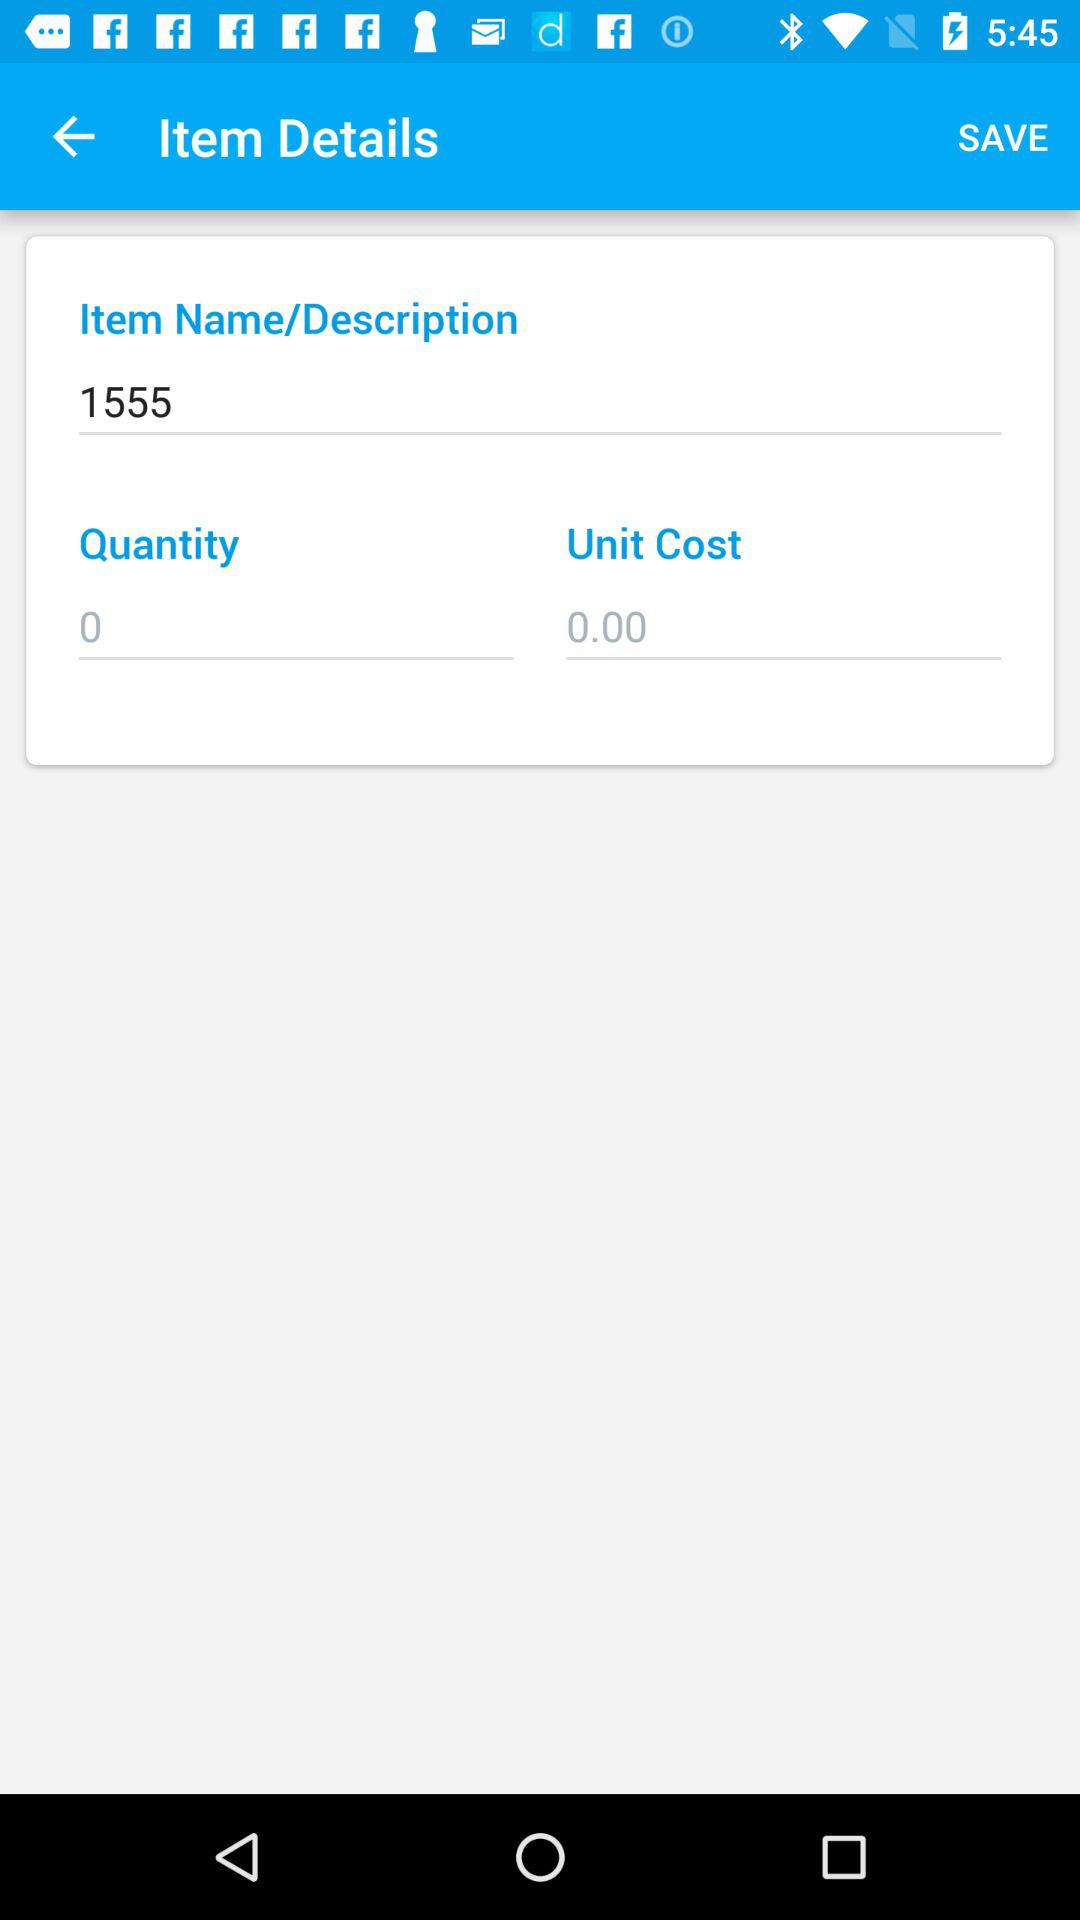What is the unit cost? The unit cost is 0. 